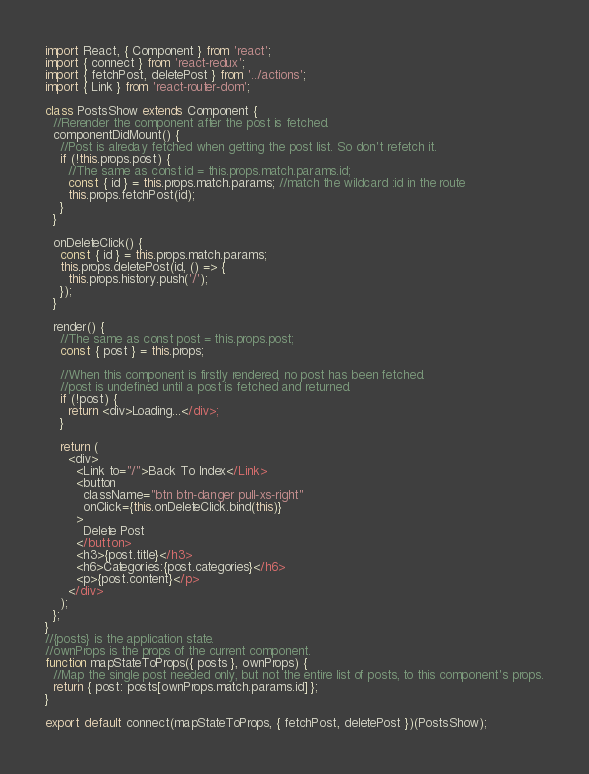<code> <loc_0><loc_0><loc_500><loc_500><_JavaScript_>import React, { Component } from 'react';
import { connect } from 'react-redux';
import { fetchPost, deletePost } from '../actions';
import { Link } from 'react-router-dom';

class PostsShow extends Component {
  //Rerender the component after the post is fetched.
  componentDidMount() {
    //Post is alreday fetched when getting the post list. So don't refetch it.
    if (!this.props.post) {
      //The same as const id = this.props.match.params.id;
      const { id } = this.props.match.params; //match the wildcard :id in the route
      this.props.fetchPost(id);
    }
  }

  onDeleteClick() {
    const { id } = this.props.match.params;
    this.props.deletePost(id, () => {
      this.props.history.push('/');
    });
  }

  render() {
    //The same as const post = this.props.post;
    const { post } = this.props;

    //When this component is firstly rendered, no post has been fetched.
    //post is undefined until a post is fetched and returned.
    if (!post) {
      return <div>Loading...</div>;
    }

    return (
      <div>
        <Link to="/">Back To Index</Link>
        <button
          className="btn btn-danger pull-xs-right"
          onClick={this.onDeleteClick.bind(this)}
        >
          Delete Post
        </button>
        <h3>{post.title}</h3>
        <h6>Categories:{post.categories}</h6>
        <p>{post.content}</p>
      </div>
    );
  };
}
//{posts} is the application state.
//ownProps is the props of the current component.
function mapStateToProps({ posts }, ownProps) {
  //Map the single post needed only, but not the entire list of posts, to this component's props.
  return { post: posts[ownProps.match.params.id] };
}

export default connect(mapStateToProps, { fetchPost, deletePost })(PostsShow);
</code> 